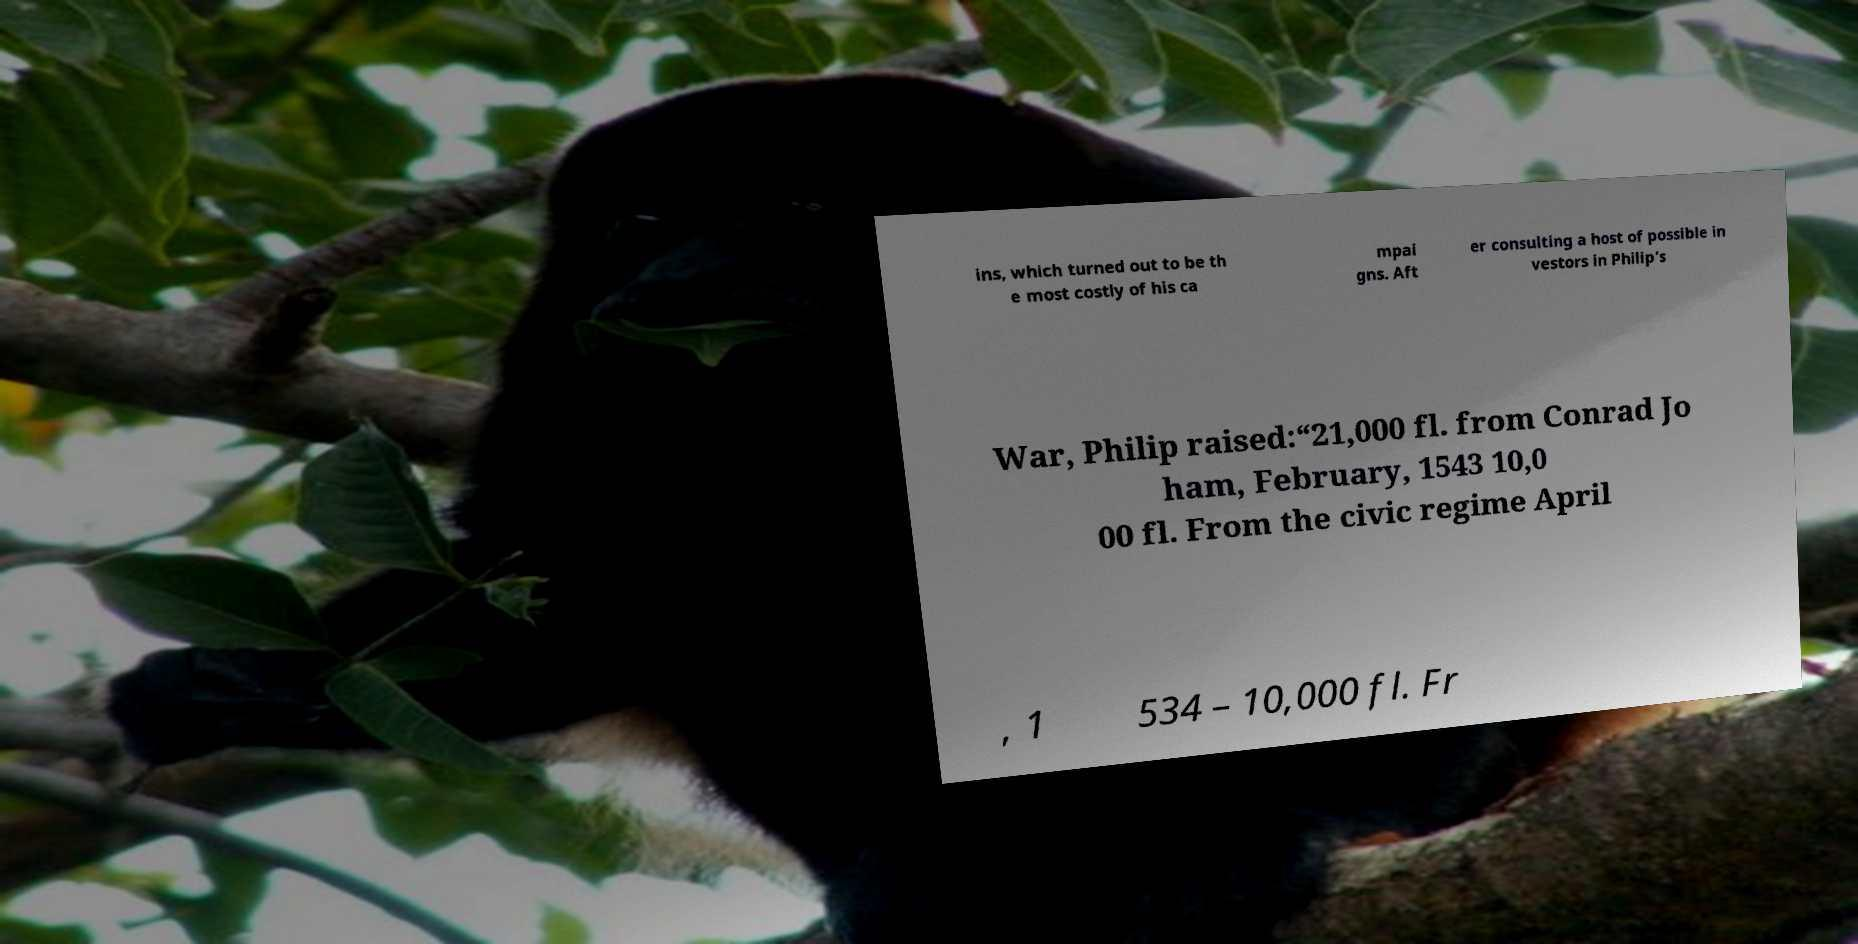Please identify and transcribe the text found in this image. ins, which turned out to be th e most costly of his ca mpai gns. Aft er consulting a host of possible in vestors in Philip’s War, Philip raised:“21,000 fl. from Conrad Jo ham, February, 1543 10,0 00 fl. From the civic regime April , 1 534 – 10,000 fl. Fr 